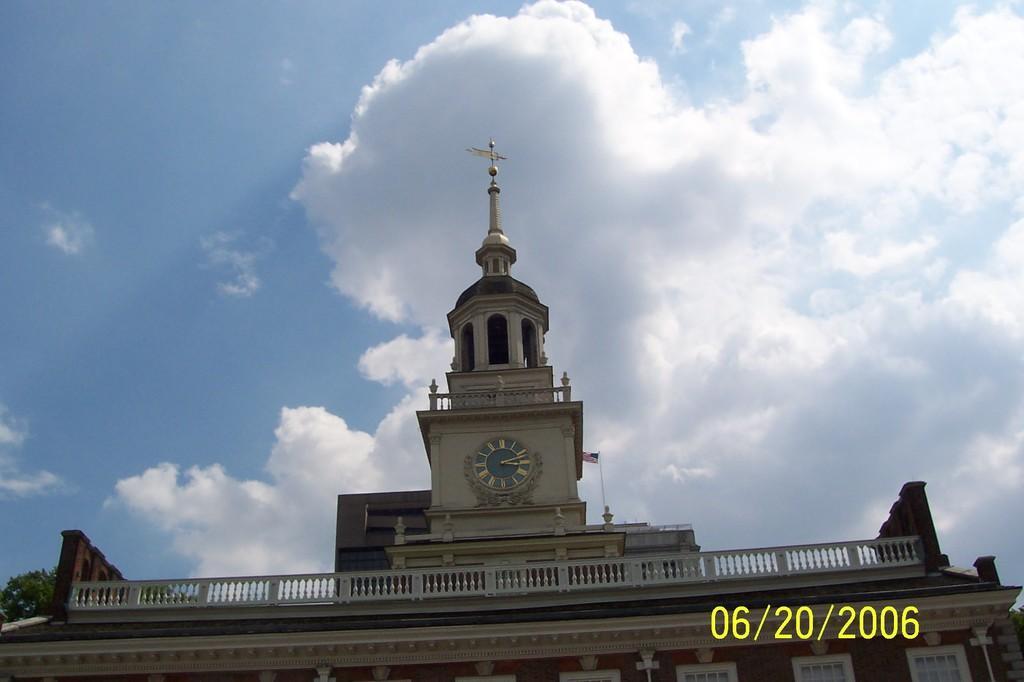How would you summarize this image in a sentence or two? This picture might be taken from outside of the building. In this image, in the middle, we can see a clock which is attached to a building, flag, tower. On the top, we can see a sky, at the bottom, we can see some windows. 